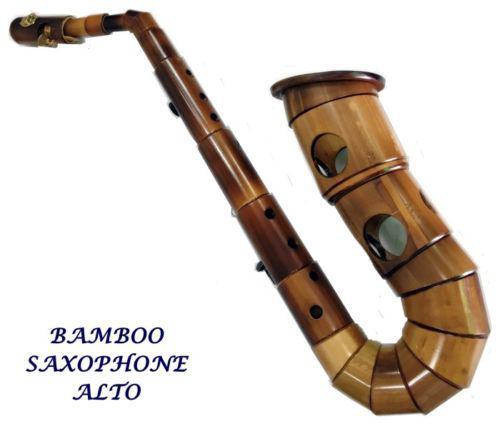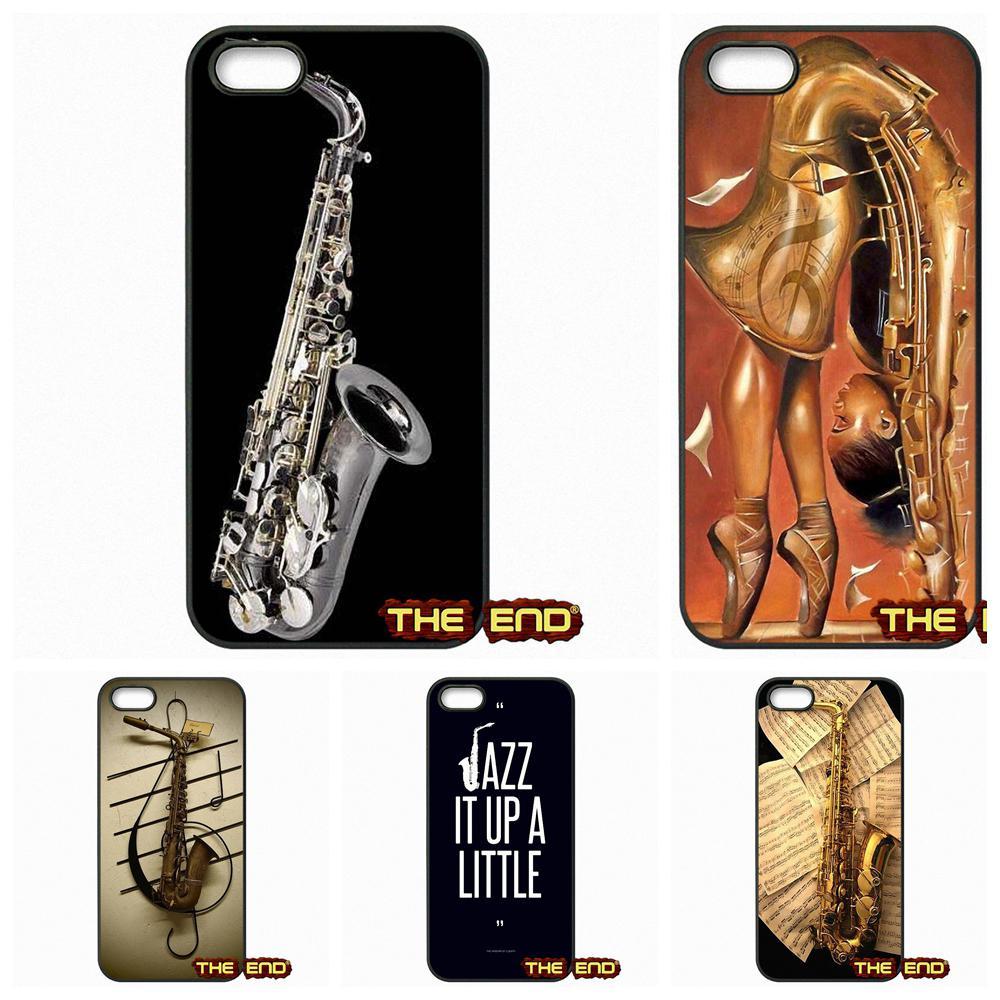The first image is the image on the left, the second image is the image on the right. Considering the images on both sides, is "There is exactly one instrument against a white background in the image on the left." valid? Answer yes or no. Yes. 